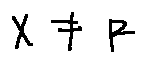<formula> <loc_0><loc_0><loc_500><loc_500>X \neq F</formula> 